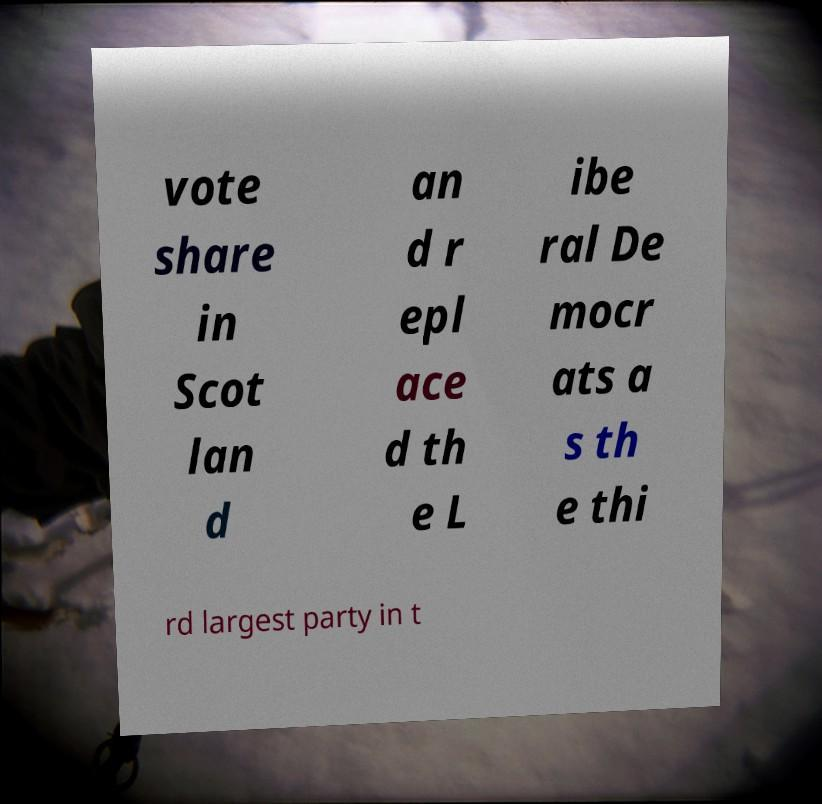Can you accurately transcribe the text from the provided image for me? vote share in Scot lan d an d r epl ace d th e L ibe ral De mocr ats a s th e thi rd largest party in t 